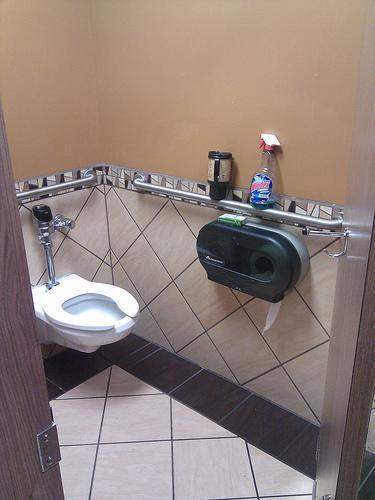How many toilets are there?
Give a very brief answer. 1. 